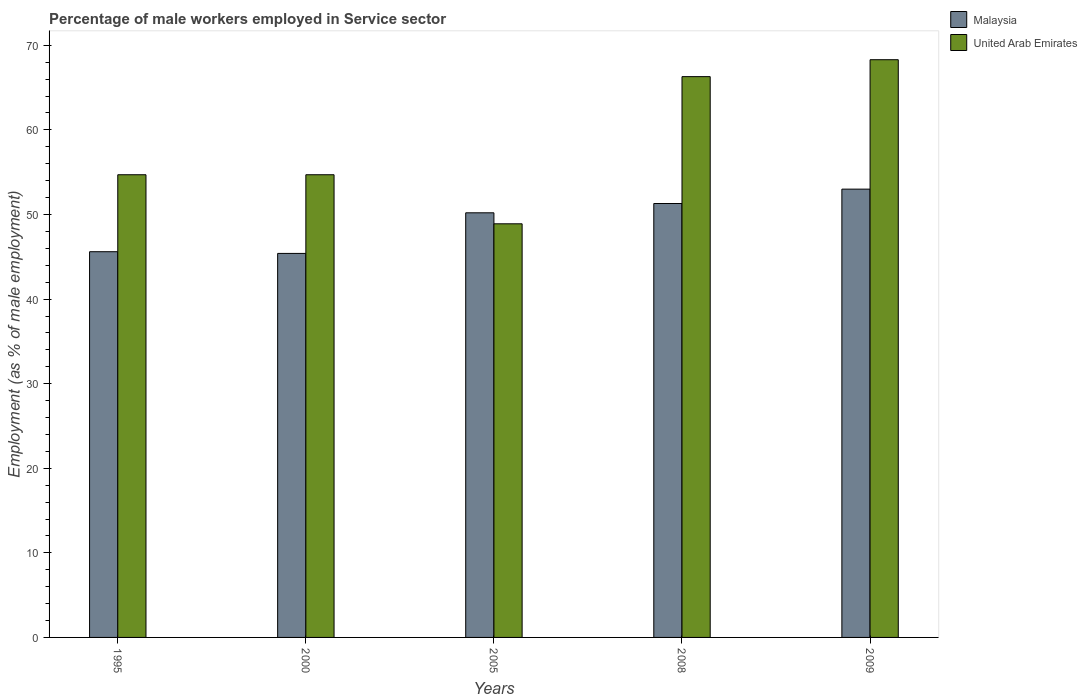How many groups of bars are there?
Your answer should be compact. 5. Are the number of bars on each tick of the X-axis equal?
Your answer should be compact. Yes. How many bars are there on the 4th tick from the left?
Provide a short and direct response. 2. In how many cases, is the number of bars for a given year not equal to the number of legend labels?
Provide a short and direct response. 0. What is the percentage of male workers employed in Service sector in United Arab Emirates in 2008?
Your answer should be very brief. 66.3. Across all years, what is the maximum percentage of male workers employed in Service sector in United Arab Emirates?
Your answer should be compact. 68.3. Across all years, what is the minimum percentage of male workers employed in Service sector in United Arab Emirates?
Offer a very short reply. 48.9. In which year was the percentage of male workers employed in Service sector in Malaysia maximum?
Your response must be concise. 2009. In which year was the percentage of male workers employed in Service sector in United Arab Emirates minimum?
Your response must be concise. 2005. What is the total percentage of male workers employed in Service sector in Malaysia in the graph?
Offer a terse response. 245.5. What is the difference between the percentage of male workers employed in Service sector in United Arab Emirates in 2000 and that in 2008?
Your answer should be compact. -11.6. What is the average percentage of male workers employed in Service sector in United Arab Emirates per year?
Keep it short and to the point. 58.58. In the year 1995, what is the difference between the percentage of male workers employed in Service sector in Malaysia and percentage of male workers employed in Service sector in United Arab Emirates?
Your response must be concise. -9.1. In how many years, is the percentage of male workers employed in Service sector in Malaysia greater than 8 %?
Offer a terse response. 5. What is the ratio of the percentage of male workers employed in Service sector in United Arab Emirates in 1995 to that in 2008?
Ensure brevity in your answer.  0.83. What is the difference between the highest and the second highest percentage of male workers employed in Service sector in Malaysia?
Your answer should be compact. 1.7. What is the difference between the highest and the lowest percentage of male workers employed in Service sector in Malaysia?
Offer a terse response. 7.6. In how many years, is the percentage of male workers employed in Service sector in Malaysia greater than the average percentage of male workers employed in Service sector in Malaysia taken over all years?
Your answer should be very brief. 3. What does the 2nd bar from the left in 1995 represents?
Your answer should be compact. United Arab Emirates. What does the 2nd bar from the right in 2008 represents?
Provide a succinct answer. Malaysia. Does the graph contain any zero values?
Your answer should be compact. No. Does the graph contain grids?
Give a very brief answer. No. What is the title of the graph?
Provide a short and direct response. Percentage of male workers employed in Service sector. What is the label or title of the Y-axis?
Offer a very short reply. Employment (as % of male employment). What is the Employment (as % of male employment) of Malaysia in 1995?
Your response must be concise. 45.6. What is the Employment (as % of male employment) in United Arab Emirates in 1995?
Give a very brief answer. 54.7. What is the Employment (as % of male employment) of Malaysia in 2000?
Provide a succinct answer. 45.4. What is the Employment (as % of male employment) of United Arab Emirates in 2000?
Give a very brief answer. 54.7. What is the Employment (as % of male employment) in Malaysia in 2005?
Your answer should be compact. 50.2. What is the Employment (as % of male employment) of United Arab Emirates in 2005?
Give a very brief answer. 48.9. What is the Employment (as % of male employment) in Malaysia in 2008?
Give a very brief answer. 51.3. What is the Employment (as % of male employment) of United Arab Emirates in 2008?
Give a very brief answer. 66.3. What is the Employment (as % of male employment) in Malaysia in 2009?
Give a very brief answer. 53. What is the Employment (as % of male employment) of United Arab Emirates in 2009?
Give a very brief answer. 68.3. Across all years, what is the maximum Employment (as % of male employment) in Malaysia?
Keep it short and to the point. 53. Across all years, what is the maximum Employment (as % of male employment) of United Arab Emirates?
Provide a succinct answer. 68.3. Across all years, what is the minimum Employment (as % of male employment) of Malaysia?
Provide a succinct answer. 45.4. Across all years, what is the minimum Employment (as % of male employment) of United Arab Emirates?
Your response must be concise. 48.9. What is the total Employment (as % of male employment) of Malaysia in the graph?
Your answer should be very brief. 245.5. What is the total Employment (as % of male employment) in United Arab Emirates in the graph?
Your response must be concise. 292.9. What is the difference between the Employment (as % of male employment) in Malaysia in 1995 and that in 2000?
Your answer should be very brief. 0.2. What is the difference between the Employment (as % of male employment) in United Arab Emirates in 1995 and that in 2000?
Ensure brevity in your answer.  0. What is the difference between the Employment (as % of male employment) of United Arab Emirates in 1995 and that in 2005?
Your response must be concise. 5.8. What is the difference between the Employment (as % of male employment) in Malaysia in 1995 and that in 2008?
Offer a terse response. -5.7. What is the difference between the Employment (as % of male employment) of United Arab Emirates in 1995 and that in 2009?
Make the answer very short. -13.6. What is the difference between the Employment (as % of male employment) of Malaysia in 2000 and that in 2008?
Give a very brief answer. -5.9. What is the difference between the Employment (as % of male employment) of Malaysia in 2000 and that in 2009?
Your answer should be compact. -7.6. What is the difference between the Employment (as % of male employment) of United Arab Emirates in 2000 and that in 2009?
Keep it short and to the point. -13.6. What is the difference between the Employment (as % of male employment) in Malaysia in 2005 and that in 2008?
Offer a terse response. -1.1. What is the difference between the Employment (as % of male employment) of United Arab Emirates in 2005 and that in 2008?
Ensure brevity in your answer.  -17.4. What is the difference between the Employment (as % of male employment) of United Arab Emirates in 2005 and that in 2009?
Give a very brief answer. -19.4. What is the difference between the Employment (as % of male employment) of United Arab Emirates in 2008 and that in 2009?
Provide a succinct answer. -2. What is the difference between the Employment (as % of male employment) in Malaysia in 1995 and the Employment (as % of male employment) in United Arab Emirates in 2008?
Offer a very short reply. -20.7. What is the difference between the Employment (as % of male employment) of Malaysia in 1995 and the Employment (as % of male employment) of United Arab Emirates in 2009?
Offer a terse response. -22.7. What is the difference between the Employment (as % of male employment) in Malaysia in 2000 and the Employment (as % of male employment) in United Arab Emirates in 2008?
Provide a succinct answer. -20.9. What is the difference between the Employment (as % of male employment) of Malaysia in 2000 and the Employment (as % of male employment) of United Arab Emirates in 2009?
Keep it short and to the point. -22.9. What is the difference between the Employment (as % of male employment) of Malaysia in 2005 and the Employment (as % of male employment) of United Arab Emirates in 2008?
Give a very brief answer. -16.1. What is the difference between the Employment (as % of male employment) in Malaysia in 2005 and the Employment (as % of male employment) in United Arab Emirates in 2009?
Offer a terse response. -18.1. What is the average Employment (as % of male employment) of Malaysia per year?
Your answer should be compact. 49.1. What is the average Employment (as % of male employment) in United Arab Emirates per year?
Your answer should be very brief. 58.58. In the year 2000, what is the difference between the Employment (as % of male employment) in Malaysia and Employment (as % of male employment) in United Arab Emirates?
Offer a very short reply. -9.3. In the year 2005, what is the difference between the Employment (as % of male employment) in Malaysia and Employment (as % of male employment) in United Arab Emirates?
Your answer should be very brief. 1.3. In the year 2008, what is the difference between the Employment (as % of male employment) in Malaysia and Employment (as % of male employment) in United Arab Emirates?
Provide a short and direct response. -15. In the year 2009, what is the difference between the Employment (as % of male employment) in Malaysia and Employment (as % of male employment) in United Arab Emirates?
Offer a terse response. -15.3. What is the ratio of the Employment (as % of male employment) in Malaysia in 1995 to that in 2000?
Make the answer very short. 1. What is the ratio of the Employment (as % of male employment) in Malaysia in 1995 to that in 2005?
Keep it short and to the point. 0.91. What is the ratio of the Employment (as % of male employment) of United Arab Emirates in 1995 to that in 2005?
Provide a short and direct response. 1.12. What is the ratio of the Employment (as % of male employment) of Malaysia in 1995 to that in 2008?
Make the answer very short. 0.89. What is the ratio of the Employment (as % of male employment) in United Arab Emirates in 1995 to that in 2008?
Give a very brief answer. 0.82. What is the ratio of the Employment (as % of male employment) of Malaysia in 1995 to that in 2009?
Provide a succinct answer. 0.86. What is the ratio of the Employment (as % of male employment) of United Arab Emirates in 1995 to that in 2009?
Offer a very short reply. 0.8. What is the ratio of the Employment (as % of male employment) in Malaysia in 2000 to that in 2005?
Give a very brief answer. 0.9. What is the ratio of the Employment (as % of male employment) in United Arab Emirates in 2000 to that in 2005?
Ensure brevity in your answer.  1.12. What is the ratio of the Employment (as % of male employment) in Malaysia in 2000 to that in 2008?
Ensure brevity in your answer.  0.89. What is the ratio of the Employment (as % of male employment) of United Arab Emirates in 2000 to that in 2008?
Ensure brevity in your answer.  0.82. What is the ratio of the Employment (as % of male employment) in Malaysia in 2000 to that in 2009?
Your response must be concise. 0.86. What is the ratio of the Employment (as % of male employment) in United Arab Emirates in 2000 to that in 2009?
Offer a terse response. 0.8. What is the ratio of the Employment (as % of male employment) in Malaysia in 2005 to that in 2008?
Your response must be concise. 0.98. What is the ratio of the Employment (as % of male employment) of United Arab Emirates in 2005 to that in 2008?
Give a very brief answer. 0.74. What is the ratio of the Employment (as % of male employment) of Malaysia in 2005 to that in 2009?
Offer a very short reply. 0.95. What is the ratio of the Employment (as % of male employment) of United Arab Emirates in 2005 to that in 2009?
Provide a short and direct response. 0.72. What is the ratio of the Employment (as % of male employment) in Malaysia in 2008 to that in 2009?
Offer a very short reply. 0.97. What is the ratio of the Employment (as % of male employment) of United Arab Emirates in 2008 to that in 2009?
Ensure brevity in your answer.  0.97. What is the difference between the highest and the second highest Employment (as % of male employment) in Malaysia?
Make the answer very short. 1.7. What is the difference between the highest and the lowest Employment (as % of male employment) in Malaysia?
Ensure brevity in your answer.  7.6. 